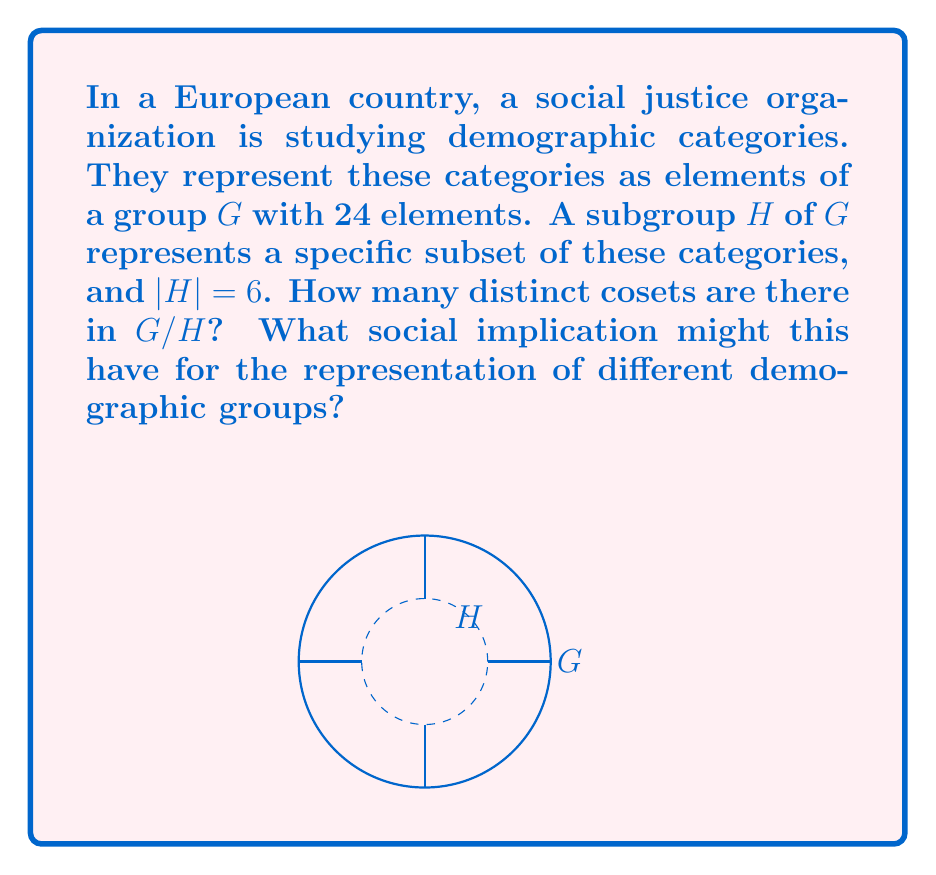Help me with this question. To solve this problem, we'll use the following steps:

1) Recall the Lagrange's Theorem: For a finite group $G$ and a subgroup $H$ of $G$, the order of $H$ divides the order of $G$. Moreover, the number of cosets of $H$ in $G$ is equal to the index of $H$ in $G$, denoted as $[G:H]$.

2) The index $[G:H]$ is calculated by:

   $$[G:H] = \frac{|G|}{|H|}$$

   where $|G|$ is the order of $G$ and $|H|$ is the order of $H$.

3) In this case, we're given:
   $|G| = 24$ (the group has 24 elements)
   $|H| = 6$ (the subgroup has 6 elements)

4) Substituting these values into the formula:

   $$[G:H] = \frac{|G|}{|H|} = \frac{24}{6} = 4$$

5) Therefore, there are 4 distinct cosets in $G/H$.

Social implication: This result suggests that the demographic categories can be divided into 4 main groups. This could imply that while there's some diversity (4 groups instead of just 1), there might still be significant underrepresentation or oversimplification of certain demographics, as complex social identities are being reduced to just 4 categories.
Answer: 4 cosets 